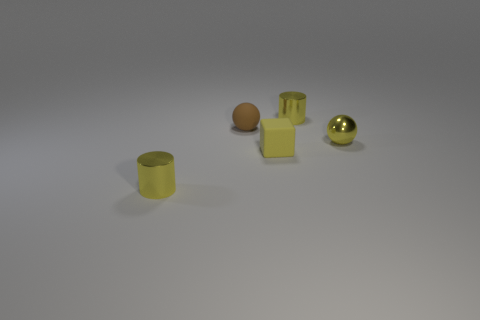Add 2 green rubber cubes. How many objects exist? 7 Subtract all cylinders. How many objects are left? 3 Subtract 0 green spheres. How many objects are left? 5 Subtract all small cylinders. Subtract all balls. How many objects are left? 1 Add 1 tiny yellow metallic objects. How many tiny yellow metallic objects are left? 4 Add 1 yellow blocks. How many yellow blocks exist? 2 